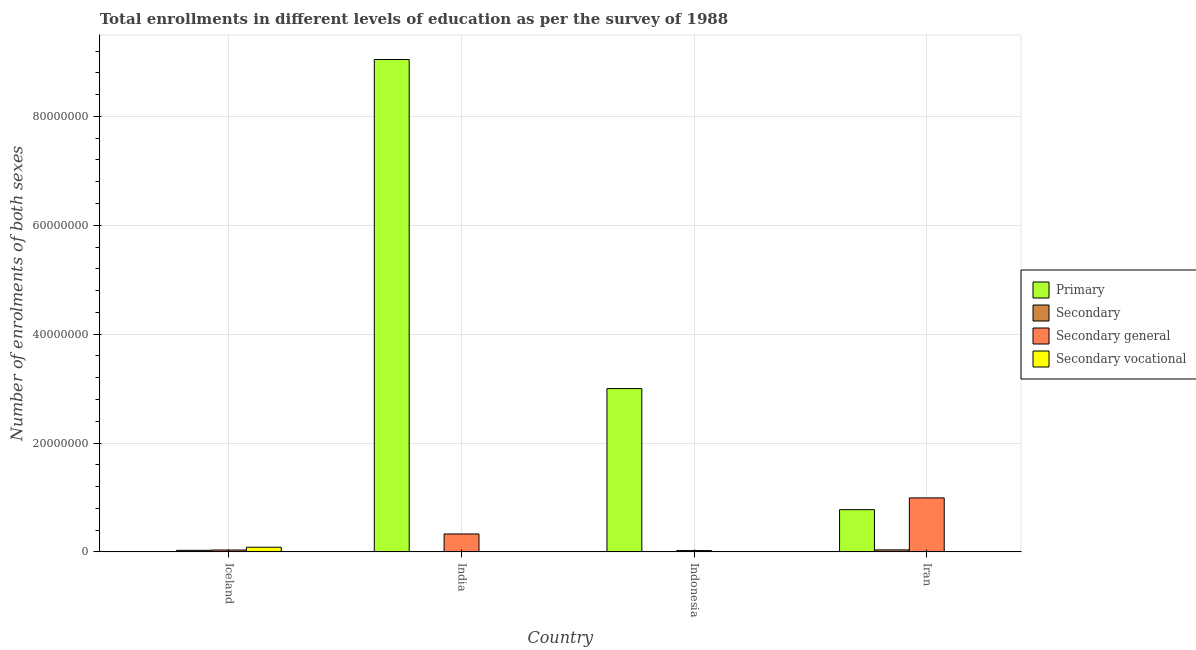How many groups of bars are there?
Offer a very short reply. 4. How many bars are there on the 1st tick from the left?
Make the answer very short. 4. How many bars are there on the 4th tick from the right?
Your answer should be compact. 4. What is the number of enrolments in secondary general education in Iran?
Your answer should be compact. 9.92e+06. Across all countries, what is the maximum number of enrolments in secondary general education?
Provide a succinct answer. 9.92e+06. Across all countries, what is the minimum number of enrolments in secondary education?
Ensure brevity in your answer.  2.25e+04. In which country was the number of enrolments in primary education maximum?
Offer a very short reply. India. In which country was the number of enrolments in secondary education minimum?
Ensure brevity in your answer.  Indonesia. What is the total number of enrolments in primary education in the graph?
Give a very brief answer. 1.28e+08. What is the difference between the number of enrolments in secondary general education in India and that in Indonesia?
Ensure brevity in your answer.  3.05e+06. What is the difference between the number of enrolments in secondary education in Iran and the number of enrolments in secondary vocational education in Indonesia?
Offer a terse response. 3.50e+05. What is the average number of enrolments in secondary education per country?
Provide a succinct answer. 1.80e+05. What is the difference between the number of enrolments in secondary education and number of enrolments in secondary vocational education in India?
Your response must be concise. 4.51e+04. What is the ratio of the number of enrolments in secondary vocational education in India to that in Iran?
Make the answer very short. 0.37. Is the number of enrolments in secondary vocational education in India less than that in Indonesia?
Your answer should be very brief. Yes. What is the difference between the highest and the second highest number of enrolments in secondary education?
Make the answer very short. 8.00e+04. What is the difference between the highest and the lowest number of enrolments in secondary general education?
Make the answer very short. 9.68e+06. In how many countries, is the number of enrolments in secondary vocational education greater than the average number of enrolments in secondary vocational education taken over all countries?
Offer a terse response. 1. Is it the case that in every country, the sum of the number of enrolments in primary education and number of enrolments in secondary vocational education is greater than the sum of number of enrolments in secondary education and number of enrolments in secondary general education?
Provide a succinct answer. No. What does the 1st bar from the left in Iceland represents?
Provide a short and direct response. Primary. What does the 4th bar from the right in India represents?
Your answer should be compact. Primary. How many bars are there?
Ensure brevity in your answer.  16. How many countries are there in the graph?
Offer a very short reply. 4. What is the difference between two consecutive major ticks on the Y-axis?
Your answer should be very brief. 2.00e+07. Does the graph contain grids?
Your answer should be compact. Yes. What is the title of the graph?
Make the answer very short. Total enrollments in different levels of education as per the survey of 1988. Does "Social Assistance" appear as one of the legend labels in the graph?
Make the answer very short. No. What is the label or title of the Y-axis?
Ensure brevity in your answer.  Number of enrolments of both sexes. What is the Number of enrolments of both sexes in Primary in Iceland?
Offer a terse response. 2.51e+04. What is the Number of enrolments of both sexes in Secondary in Iceland?
Your response must be concise. 2.86e+05. What is the Number of enrolments of both sexes of Secondary general in Iceland?
Give a very brief answer. 3.42e+05. What is the Number of enrolments of both sexes in Secondary vocational in Iceland?
Your answer should be compact. 8.54e+05. What is the Number of enrolments of both sexes in Primary in India?
Keep it short and to the point. 9.05e+07. What is the Number of enrolments of both sexes of Secondary in India?
Keep it short and to the point. 4.60e+04. What is the Number of enrolments of both sexes in Secondary general in India?
Your answer should be very brief. 3.29e+06. What is the Number of enrolments of both sexes of Secondary vocational in India?
Ensure brevity in your answer.  836. What is the Number of enrolments of both sexes in Primary in Indonesia?
Provide a succinct answer. 3.00e+07. What is the Number of enrolments of both sexes in Secondary in Indonesia?
Keep it short and to the point. 2.25e+04. What is the Number of enrolments of both sexes in Secondary general in Indonesia?
Provide a succinct answer. 2.39e+05. What is the Number of enrolments of both sexes in Secondary vocational in Indonesia?
Keep it short and to the point. 1.63e+04. What is the Number of enrolments of both sexes in Primary in Iran?
Offer a very short reply. 7.76e+06. What is the Number of enrolments of both sexes of Secondary in Iran?
Provide a short and direct response. 3.66e+05. What is the Number of enrolments of both sexes of Secondary general in Iran?
Give a very brief answer. 9.92e+06. What is the Number of enrolments of both sexes of Secondary vocational in Iran?
Offer a very short reply. 2256. Across all countries, what is the maximum Number of enrolments of both sexes in Primary?
Provide a short and direct response. 9.05e+07. Across all countries, what is the maximum Number of enrolments of both sexes of Secondary?
Provide a succinct answer. 3.66e+05. Across all countries, what is the maximum Number of enrolments of both sexes of Secondary general?
Your answer should be compact. 9.92e+06. Across all countries, what is the maximum Number of enrolments of both sexes of Secondary vocational?
Make the answer very short. 8.54e+05. Across all countries, what is the minimum Number of enrolments of both sexes of Primary?
Keep it short and to the point. 2.51e+04. Across all countries, what is the minimum Number of enrolments of both sexes of Secondary?
Offer a very short reply. 2.25e+04. Across all countries, what is the minimum Number of enrolments of both sexes in Secondary general?
Offer a very short reply. 2.39e+05. Across all countries, what is the minimum Number of enrolments of both sexes of Secondary vocational?
Provide a short and direct response. 836. What is the total Number of enrolments of both sexes of Primary in the graph?
Your answer should be very brief. 1.28e+08. What is the total Number of enrolments of both sexes in Secondary in the graph?
Offer a terse response. 7.21e+05. What is the total Number of enrolments of both sexes in Secondary general in the graph?
Make the answer very short. 1.38e+07. What is the total Number of enrolments of both sexes in Secondary vocational in the graph?
Offer a very short reply. 8.73e+05. What is the difference between the Number of enrolments of both sexes of Primary in Iceland and that in India?
Provide a short and direct response. -9.04e+07. What is the difference between the Number of enrolments of both sexes in Secondary in Iceland and that in India?
Your answer should be very brief. 2.40e+05. What is the difference between the Number of enrolments of both sexes in Secondary general in Iceland and that in India?
Make the answer very short. -2.95e+06. What is the difference between the Number of enrolments of both sexes in Secondary vocational in Iceland and that in India?
Offer a terse response. 8.53e+05. What is the difference between the Number of enrolments of both sexes of Primary in Iceland and that in Indonesia?
Offer a very short reply. -3.00e+07. What is the difference between the Number of enrolments of both sexes in Secondary in Iceland and that in Indonesia?
Give a very brief answer. 2.64e+05. What is the difference between the Number of enrolments of both sexes in Secondary general in Iceland and that in Indonesia?
Your answer should be very brief. 1.03e+05. What is the difference between the Number of enrolments of both sexes in Secondary vocational in Iceland and that in Indonesia?
Your response must be concise. 8.37e+05. What is the difference between the Number of enrolments of both sexes of Primary in Iceland and that in Iran?
Give a very brief answer. -7.73e+06. What is the difference between the Number of enrolments of both sexes of Secondary in Iceland and that in Iran?
Ensure brevity in your answer.  -8.00e+04. What is the difference between the Number of enrolments of both sexes in Secondary general in Iceland and that in Iran?
Provide a succinct answer. -9.57e+06. What is the difference between the Number of enrolments of both sexes in Secondary vocational in Iceland and that in Iran?
Provide a short and direct response. 8.51e+05. What is the difference between the Number of enrolments of both sexes in Primary in India and that in Indonesia?
Your response must be concise. 6.05e+07. What is the difference between the Number of enrolments of both sexes of Secondary in India and that in Indonesia?
Provide a short and direct response. 2.35e+04. What is the difference between the Number of enrolments of both sexes of Secondary general in India and that in Indonesia?
Your answer should be compact. 3.05e+06. What is the difference between the Number of enrolments of both sexes in Secondary vocational in India and that in Indonesia?
Make the answer very short. -1.55e+04. What is the difference between the Number of enrolments of both sexes in Primary in India and that in Iran?
Keep it short and to the point. 8.27e+07. What is the difference between the Number of enrolments of both sexes in Secondary in India and that in Iran?
Your response must be concise. -3.21e+05. What is the difference between the Number of enrolments of both sexes of Secondary general in India and that in Iran?
Make the answer very short. -6.63e+06. What is the difference between the Number of enrolments of both sexes of Secondary vocational in India and that in Iran?
Offer a very short reply. -1420. What is the difference between the Number of enrolments of both sexes of Primary in Indonesia and that in Iran?
Your response must be concise. 2.22e+07. What is the difference between the Number of enrolments of both sexes of Secondary in Indonesia and that in Iran?
Offer a terse response. -3.44e+05. What is the difference between the Number of enrolments of both sexes in Secondary general in Indonesia and that in Iran?
Make the answer very short. -9.68e+06. What is the difference between the Number of enrolments of both sexes in Secondary vocational in Indonesia and that in Iran?
Give a very brief answer. 1.40e+04. What is the difference between the Number of enrolments of both sexes in Primary in Iceland and the Number of enrolments of both sexes in Secondary in India?
Provide a succinct answer. -2.08e+04. What is the difference between the Number of enrolments of both sexes of Primary in Iceland and the Number of enrolments of both sexes of Secondary general in India?
Keep it short and to the point. -3.27e+06. What is the difference between the Number of enrolments of both sexes in Primary in Iceland and the Number of enrolments of both sexes in Secondary vocational in India?
Ensure brevity in your answer.  2.43e+04. What is the difference between the Number of enrolments of both sexes in Secondary in Iceland and the Number of enrolments of both sexes in Secondary general in India?
Provide a short and direct response. -3.00e+06. What is the difference between the Number of enrolments of both sexes of Secondary in Iceland and the Number of enrolments of both sexes of Secondary vocational in India?
Make the answer very short. 2.86e+05. What is the difference between the Number of enrolments of both sexes of Secondary general in Iceland and the Number of enrolments of both sexes of Secondary vocational in India?
Ensure brevity in your answer.  3.41e+05. What is the difference between the Number of enrolments of both sexes of Primary in Iceland and the Number of enrolments of both sexes of Secondary in Indonesia?
Offer a very short reply. 2612. What is the difference between the Number of enrolments of both sexes of Primary in Iceland and the Number of enrolments of both sexes of Secondary general in Indonesia?
Keep it short and to the point. -2.14e+05. What is the difference between the Number of enrolments of both sexes in Primary in Iceland and the Number of enrolments of both sexes in Secondary vocational in Indonesia?
Give a very brief answer. 8815. What is the difference between the Number of enrolments of both sexes in Secondary in Iceland and the Number of enrolments of both sexes in Secondary general in Indonesia?
Give a very brief answer. 4.77e+04. What is the difference between the Number of enrolments of both sexes of Secondary in Iceland and the Number of enrolments of both sexes of Secondary vocational in Indonesia?
Your answer should be compact. 2.70e+05. What is the difference between the Number of enrolments of both sexes in Secondary general in Iceland and the Number of enrolments of both sexes in Secondary vocational in Indonesia?
Make the answer very short. 3.26e+05. What is the difference between the Number of enrolments of both sexes in Primary in Iceland and the Number of enrolments of both sexes in Secondary in Iran?
Ensure brevity in your answer.  -3.41e+05. What is the difference between the Number of enrolments of both sexes in Primary in Iceland and the Number of enrolments of both sexes in Secondary general in Iran?
Keep it short and to the point. -9.89e+06. What is the difference between the Number of enrolments of both sexes of Primary in Iceland and the Number of enrolments of both sexes of Secondary vocational in Iran?
Offer a very short reply. 2.29e+04. What is the difference between the Number of enrolments of both sexes of Secondary in Iceland and the Number of enrolments of both sexes of Secondary general in Iran?
Ensure brevity in your answer.  -9.63e+06. What is the difference between the Number of enrolments of both sexes of Secondary in Iceland and the Number of enrolments of both sexes of Secondary vocational in Iran?
Provide a succinct answer. 2.84e+05. What is the difference between the Number of enrolments of both sexes of Secondary general in Iceland and the Number of enrolments of both sexes of Secondary vocational in Iran?
Provide a succinct answer. 3.40e+05. What is the difference between the Number of enrolments of both sexes of Primary in India and the Number of enrolments of both sexes of Secondary in Indonesia?
Make the answer very short. 9.04e+07. What is the difference between the Number of enrolments of both sexes in Primary in India and the Number of enrolments of both sexes in Secondary general in Indonesia?
Keep it short and to the point. 9.02e+07. What is the difference between the Number of enrolments of both sexes of Primary in India and the Number of enrolments of both sexes of Secondary vocational in Indonesia?
Your answer should be compact. 9.04e+07. What is the difference between the Number of enrolments of both sexes in Secondary in India and the Number of enrolments of both sexes in Secondary general in Indonesia?
Offer a terse response. -1.93e+05. What is the difference between the Number of enrolments of both sexes of Secondary in India and the Number of enrolments of both sexes of Secondary vocational in Indonesia?
Give a very brief answer. 2.97e+04. What is the difference between the Number of enrolments of both sexes of Secondary general in India and the Number of enrolments of both sexes of Secondary vocational in Indonesia?
Your answer should be compact. 3.27e+06. What is the difference between the Number of enrolments of both sexes of Primary in India and the Number of enrolments of both sexes of Secondary in Iran?
Keep it short and to the point. 9.01e+07. What is the difference between the Number of enrolments of both sexes in Primary in India and the Number of enrolments of both sexes in Secondary general in Iran?
Make the answer very short. 8.05e+07. What is the difference between the Number of enrolments of both sexes in Primary in India and the Number of enrolments of both sexes in Secondary vocational in Iran?
Your answer should be compact. 9.05e+07. What is the difference between the Number of enrolments of both sexes in Secondary in India and the Number of enrolments of both sexes in Secondary general in Iran?
Your answer should be very brief. -9.87e+06. What is the difference between the Number of enrolments of both sexes in Secondary in India and the Number of enrolments of both sexes in Secondary vocational in Iran?
Ensure brevity in your answer.  4.37e+04. What is the difference between the Number of enrolments of both sexes in Secondary general in India and the Number of enrolments of both sexes in Secondary vocational in Iran?
Provide a short and direct response. 3.29e+06. What is the difference between the Number of enrolments of both sexes in Primary in Indonesia and the Number of enrolments of both sexes in Secondary in Iran?
Your response must be concise. 2.96e+07. What is the difference between the Number of enrolments of both sexes of Primary in Indonesia and the Number of enrolments of both sexes of Secondary general in Iran?
Offer a terse response. 2.01e+07. What is the difference between the Number of enrolments of both sexes of Primary in Indonesia and the Number of enrolments of both sexes of Secondary vocational in Iran?
Provide a succinct answer. 3.00e+07. What is the difference between the Number of enrolments of both sexes in Secondary in Indonesia and the Number of enrolments of both sexes in Secondary general in Iran?
Make the answer very short. -9.89e+06. What is the difference between the Number of enrolments of both sexes in Secondary in Indonesia and the Number of enrolments of both sexes in Secondary vocational in Iran?
Offer a terse response. 2.02e+04. What is the difference between the Number of enrolments of both sexes of Secondary general in Indonesia and the Number of enrolments of both sexes of Secondary vocational in Iran?
Give a very brief answer. 2.37e+05. What is the average Number of enrolments of both sexes in Primary per country?
Make the answer very short. 3.21e+07. What is the average Number of enrolments of both sexes of Secondary per country?
Keep it short and to the point. 1.80e+05. What is the average Number of enrolments of both sexes in Secondary general per country?
Your answer should be compact. 3.45e+06. What is the average Number of enrolments of both sexes of Secondary vocational per country?
Your answer should be compact. 2.18e+05. What is the difference between the Number of enrolments of both sexes in Primary and Number of enrolments of both sexes in Secondary in Iceland?
Make the answer very short. -2.61e+05. What is the difference between the Number of enrolments of both sexes of Primary and Number of enrolments of both sexes of Secondary general in Iceland?
Provide a short and direct response. -3.17e+05. What is the difference between the Number of enrolments of both sexes in Primary and Number of enrolments of both sexes in Secondary vocational in Iceland?
Ensure brevity in your answer.  -8.28e+05. What is the difference between the Number of enrolments of both sexes of Secondary and Number of enrolments of both sexes of Secondary general in Iceland?
Provide a succinct answer. -5.54e+04. What is the difference between the Number of enrolments of both sexes in Secondary and Number of enrolments of both sexes in Secondary vocational in Iceland?
Your answer should be compact. -5.67e+05. What is the difference between the Number of enrolments of both sexes in Secondary general and Number of enrolments of both sexes in Secondary vocational in Iceland?
Your response must be concise. -5.12e+05. What is the difference between the Number of enrolments of both sexes in Primary and Number of enrolments of both sexes in Secondary in India?
Ensure brevity in your answer.  9.04e+07. What is the difference between the Number of enrolments of both sexes in Primary and Number of enrolments of both sexes in Secondary general in India?
Provide a short and direct response. 8.72e+07. What is the difference between the Number of enrolments of both sexes of Primary and Number of enrolments of both sexes of Secondary vocational in India?
Offer a very short reply. 9.05e+07. What is the difference between the Number of enrolments of both sexes in Secondary and Number of enrolments of both sexes in Secondary general in India?
Keep it short and to the point. -3.24e+06. What is the difference between the Number of enrolments of both sexes in Secondary and Number of enrolments of both sexes in Secondary vocational in India?
Provide a short and direct response. 4.51e+04. What is the difference between the Number of enrolments of both sexes of Secondary general and Number of enrolments of both sexes of Secondary vocational in India?
Offer a very short reply. 3.29e+06. What is the difference between the Number of enrolments of both sexes in Primary and Number of enrolments of both sexes in Secondary in Indonesia?
Make the answer very short. 3.00e+07. What is the difference between the Number of enrolments of both sexes in Primary and Number of enrolments of both sexes in Secondary general in Indonesia?
Keep it short and to the point. 2.98e+07. What is the difference between the Number of enrolments of both sexes of Primary and Number of enrolments of both sexes of Secondary vocational in Indonesia?
Keep it short and to the point. 3.00e+07. What is the difference between the Number of enrolments of both sexes of Secondary and Number of enrolments of both sexes of Secondary general in Indonesia?
Your response must be concise. -2.16e+05. What is the difference between the Number of enrolments of both sexes in Secondary and Number of enrolments of both sexes in Secondary vocational in Indonesia?
Offer a very short reply. 6203. What is the difference between the Number of enrolments of both sexes of Secondary general and Number of enrolments of both sexes of Secondary vocational in Indonesia?
Offer a very short reply. 2.22e+05. What is the difference between the Number of enrolments of both sexes in Primary and Number of enrolments of both sexes in Secondary in Iran?
Give a very brief answer. 7.39e+06. What is the difference between the Number of enrolments of both sexes of Primary and Number of enrolments of both sexes of Secondary general in Iran?
Give a very brief answer. -2.16e+06. What is the difference between the Number of enrolments of both sexes in Primary and Number of enrolments of both sexes in Secondary vocational in Iran?
Provide a succinct answer. 7.76e+06. What is the difference between the Number of enrolments of both sexes of Secondary and Number of enrolments of both sexes of Secondary general in Iran?
Make the answer very short. -9.55e+06. What is the difference between the Number of enrolments of both sexes in Secondary and Number of enrolments of both sexes in Secondary vocational in Iran?
Provide a short and direct response. 3.64e+05. What is the difference between the Number of enrolments of both sexes of Secondary general and Number of enrolments of both sexes of Secondary vocational in Iran?
Provide a succinct answer. 9.91e+06. What is the ratio of the Number of enrolments of both sexes in Primary in Iceland to that in India?
Offer a very short reply. 0. What is the ratio of the Number of enrolments of both sexes in Secondary in Iceland to that in India?
Your answer should be very brief. 6.23. What is the ratio of the Number of enrolments of both sexes of Secondary general in Iceland to that in India?
Provide a short and direct response. 0.1. What is the ratio of the Number of enrolments of both sexes of Secondary vocational in Iceland to that in India?
Your answer should be compact. 1020.95. What is the ratio of the Number of enrolments of both sexes of Primary in Iceland to that in Indonesia?
Make the answer very short. 0. What is the ratio of the Number of enrolments of both sexes in Secondary in Iceland to that in Indonesia?
Provide a short and direct response. 12.73. What is the ratio of the Number of enrolments of both sexes of Secondary general in Iceland to that in Indonesia?
Your answer should be very brief. 1.43. What is the ratio of the Number of enrolments of both sexes of Secondary vocational in Iceland to that in Indonesia?
Provide a short and direct response. 52.39. What is the ratio of the Number of enrolments of both sexes of Primary in Iceland to that in Iran?
Offer a very short reply. 0. What is the ratio of the Number of enrolments of both sexes of Secondary in Iceland to that in Iran?
Your answer should be very brief. 0.78. What is the ratio of the Number of enrolments of both sexes in Secondary general in Iceland to that in Iran?
Provide a short and direct response. 0.03. What is the ratio of the Number of enrolments of both sexes of Secondary vocational in Iceland to that in Iran?
Provide a short and direct response. 378.33. What is the ratio of the Number of enrolments of both sexes of Primary in India to that in Indonesia?
Provide a short and direct response. 3.02. What is the ratio of the Number of enrolments of both sexes of Secondary in India to that in Indonesia?
Give a very brief answer. 2.04. What is the ratio of the Number of enrolments of both sexes of Secondary general in India to that in Indonesia?
Offer a very short reply. 13.78. What is the ratio of the Number of enrolments of both sexes in Secondary vocational in India to that in Indonesia?
Offer a terse response. 0.05. What is the ratio of the Number of enrolments of both sexes of Primary in India to that in Iran?
Provide a succinct answer. 11.66. What is the ratio of the Number of enrolments of both sexes of Secondary in India to that in Iran?
Your answer should be compact. 0.13. What is the ratio of the Number of enrolments of both sexes in Secondary general in India to that in Iran?
Give a very brief answer. 0.33. What is the ratio of the Number of enrolments of both sexes in Secondary vocational in India to that in Iran?
Provide a succinct answer. 0.37. What is the ratio of the Number of enrolments of both sexes in Primary in Indonesia to that in Iran?
Your response must be concise. 3.87. What is the ratio of the Number of enrolments of both sexes of Secondary in Indonesia to that in Iran?
Offer a very short reply. 0.06. What is the ratio of the Number of enrolments of both sexes in Secondary general in Indonesia to that in Iran?
Ensure brevity in your answer.  0.02. What is the ratio of the Number of enrolments of both sexes of Secondary vocational in Indonesia to that in Iran?
Keep it short and to the point. 7.22. What is the difference between the highest and the second highest Number of enrolments of both sexes in Primary?
Provide a succinct answer. 6.05e+07. What is the difference between the highest and the second highest Number of enrolments of both sexes in Secondary?
Your answer should be compact. 8.00e+04. What is the difference between the highest and the second highest Number of enrolments of both sexes of Secondary general?
Your answer should be very brief. 6.63e+06. What is the difference between the highest and the second highest Number of enrolments of both sexes in Secondary vocational?
Keep it short and to the point. 8.37e+05. What is the difference between the highest and the lowest Number of enrolments of both sexes of Primary?
Your answer should be very brief. 9.04e+07. What is the difference between the highest and the lowest Number of enrolments of both sexes of Secondary?
Provide a short and direct response. 3.44e+05. What is the difference between the highest and the lowest Number of enrolments of both sexes in Secondary general?
Ensure brevity in your answer.  9.68e+06. What is the difference between the highest and the lowest Number of enrolments of both sexes of Secondary vocational?
Provide a short and direct response. 8.53e+05. 